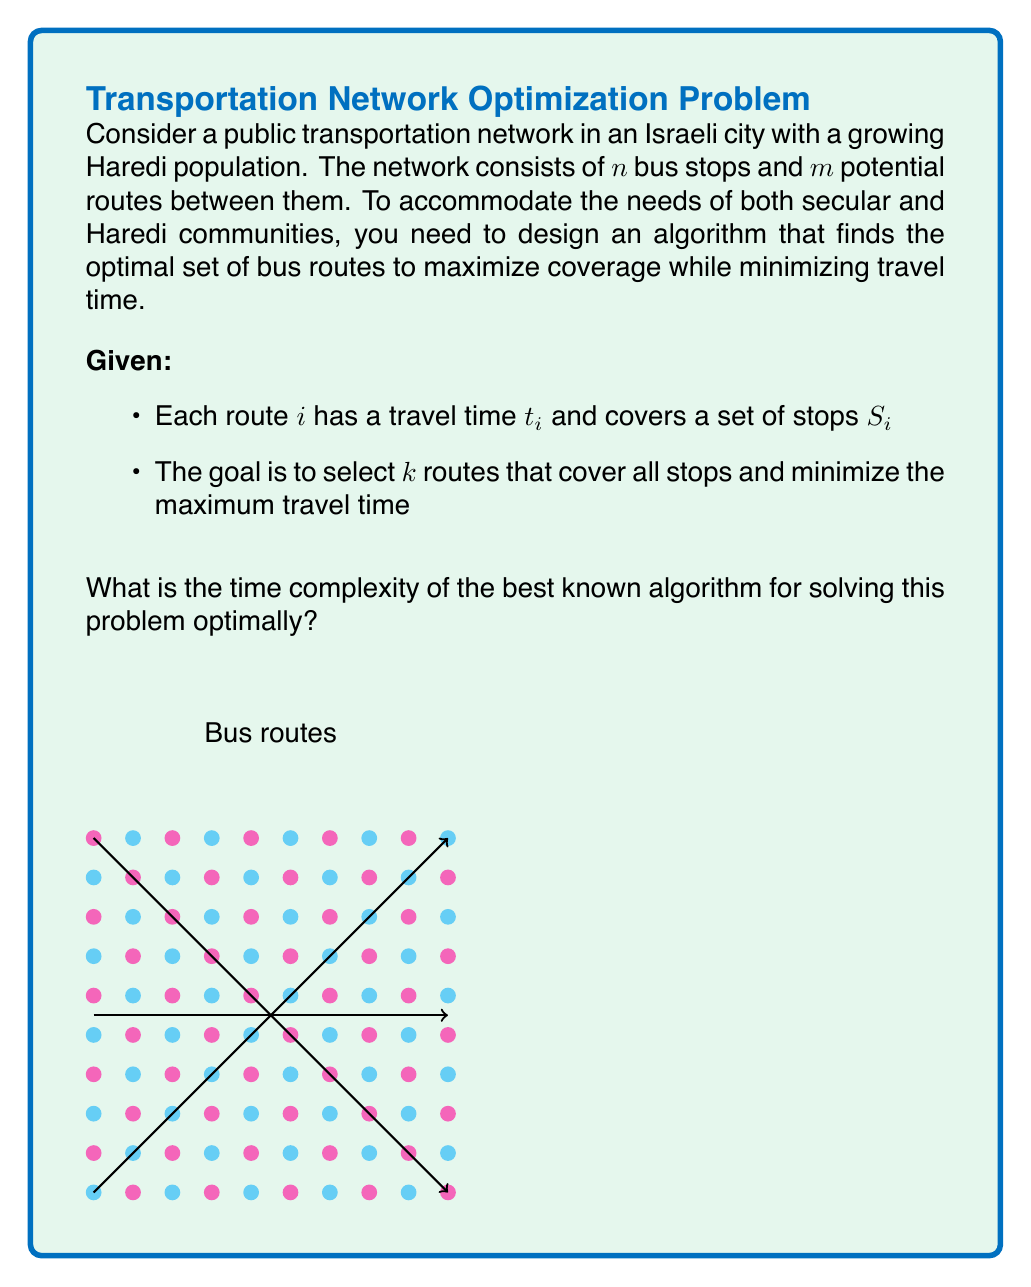Could you help me with this problem? To solve this problem optimally, we need to consider the following steps:

1) The problem described is a variant of the Set Cover problem, which is known to be NP-hard.

2) The best known exact algorithm for Set Cover uses dynamic programming over subsets:

   Let $T(U)$ be the minimum time to cover a subset $U$ of stops.
   $$T(U) = \min_{i: S_i \subseteq U} \{\max(t_i, T(U \setminus S_i))\}$$

3) The time complexity of this dynamic programming approach is $O(2^n \cdot m)$, where:
   - $2^n$ represents all possible subsets of $n$ stops
   - $m$ is the number of potential routes to consider for each subset

4) However, our problem has an additional constraint of selecting exactly $k$ routes. This can be incorporated by adding a dimension to our dynamic programming table:

   Let $T(U, j)$ be the minimum time to cover subset $U$ using exactly $j$ routes.
   $$T(U, j) = \min_{i: S_i \subseteq U} \{\max(t_i, T(U \setminus S_i, j-1))\}$$

5) This modification increases the time complexity to $O(2^n \cdot k \cdot m)$.

6) The space complexity is $O(2^n \cdot k)$ to store the dynamic programming table.

7) While this algorithm solves the problem optimally, it's important to note that for practical applications with large $n$, approximation algorithms or heuristics might be more suitable due to the exponential time complexity.
Answer: $O(2^n \cdot k \cdot m)$ 